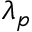Convert formula to latex. <formula><loc_0><loc_0><loc_500><loc_500>\lambda _ { p }</formula> 